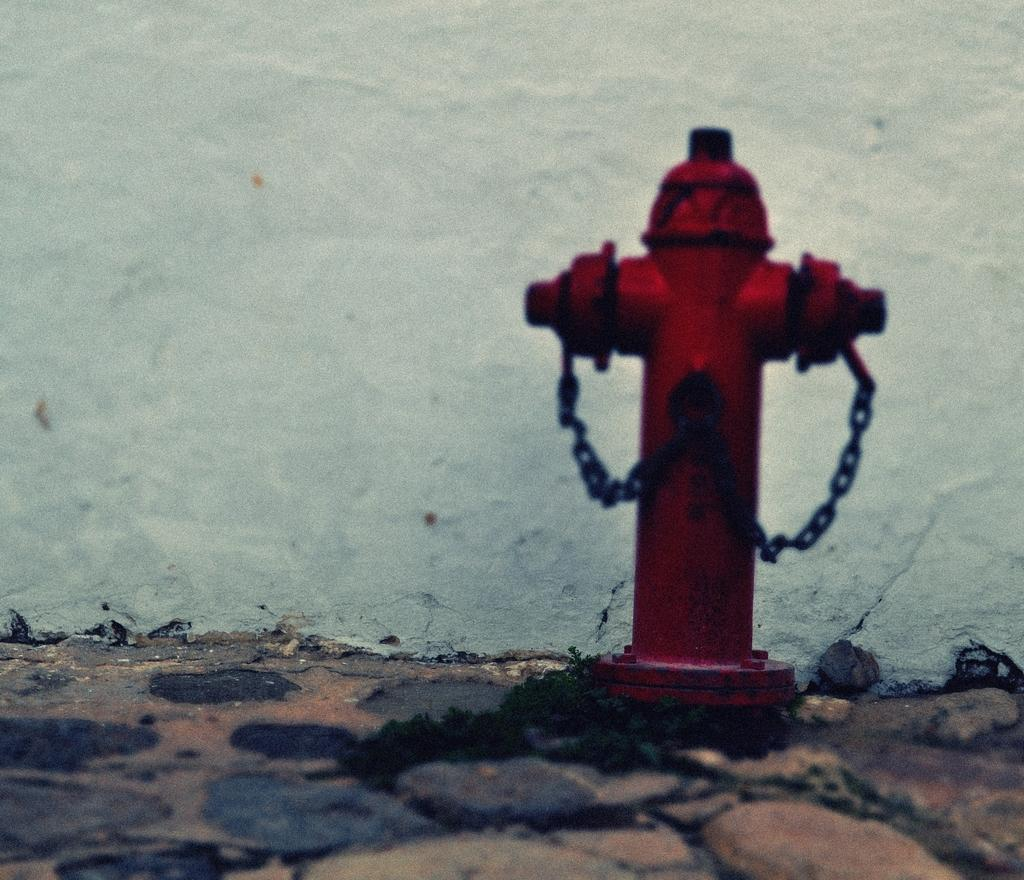Where was the image taken? The image is taken outdoors. What is at the bottom of the image? There is a floor at the bottom of the image. What can be seen in the background of the image? There is a wall in the background of the image. What is the main object in the middle of the image? There is a hydrant in the middle of the image. Where is the hydrant located in relation to the floor? The hydrant is on the floor. How many trees are growing on the hydrant in the image? There are no trees growing on the hydrant in the image. What is the purpose of the point on the wall in the image? There is no point on the wall in the image. 